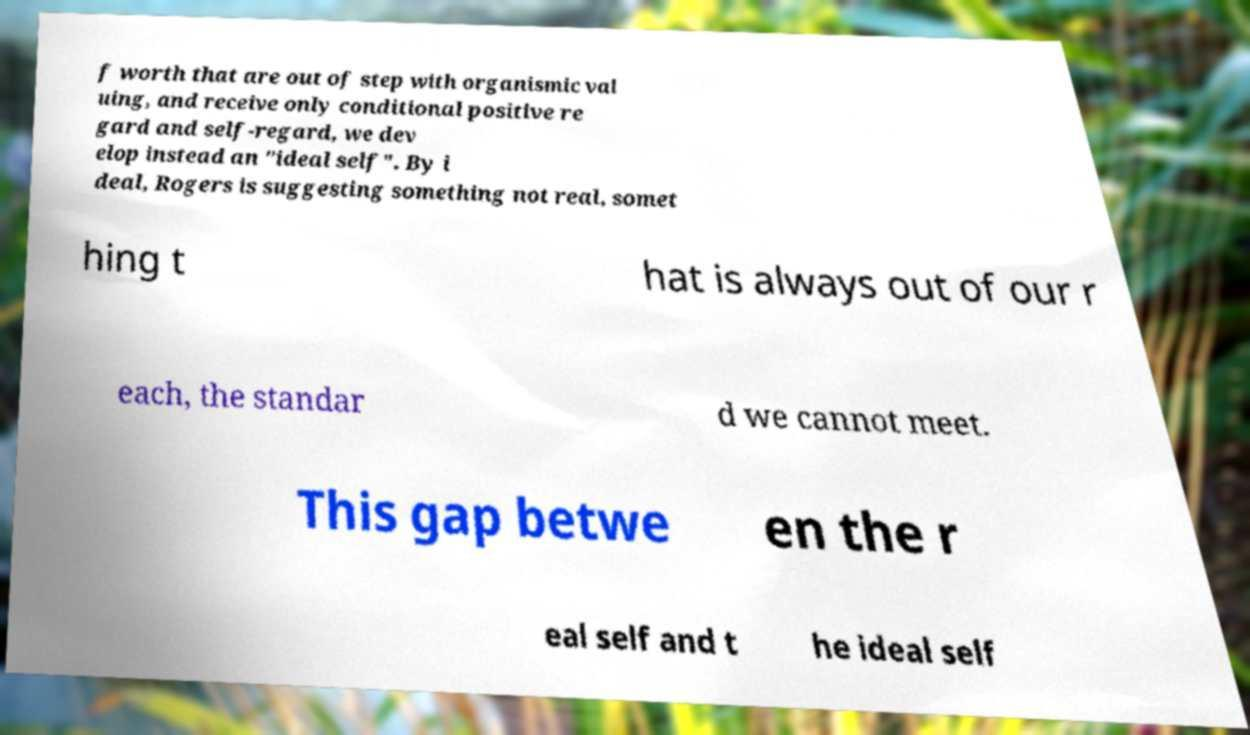Please identify and transcribe the text found in this image. f worth that are out of step with organismic val uing, and receive only conditional positive re gard and self-regard, we dev elop instead an "ideal self". By i deal, Rogers is suggesting something not real, somet hing t hat is always out of our r each, the standar d we cannot meet. This gap betwe en the r eal self and t he ideal self 